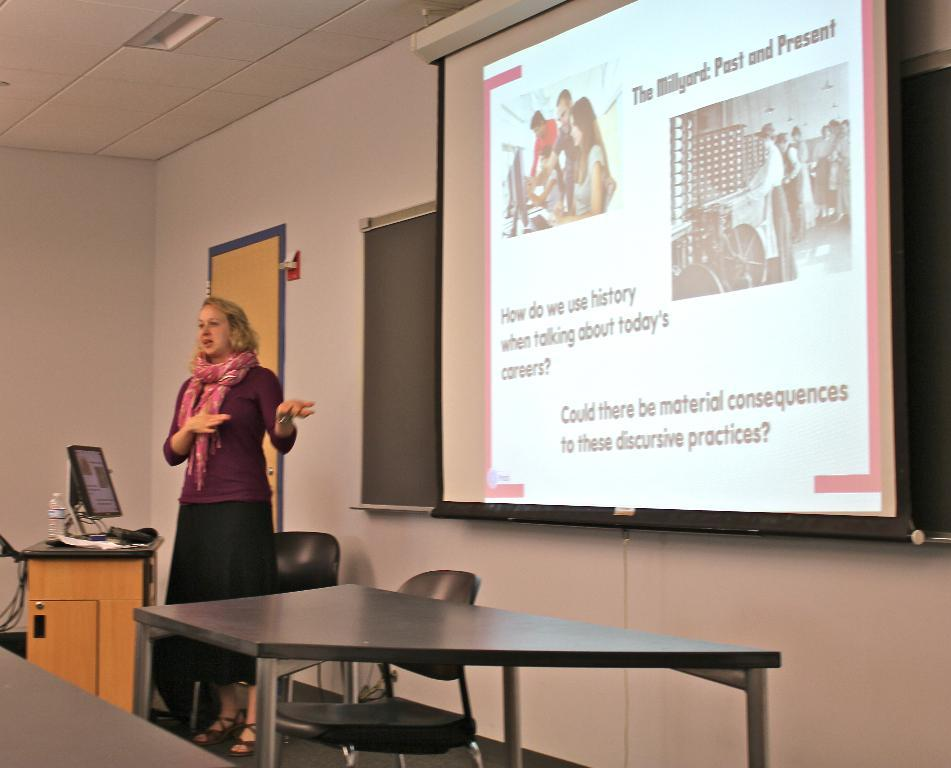Who is present in the image? There is a woman in the image. What is the woman doing in the image? The woman is standing in the image. What can be seen on the wall or screen in the image? There is a projected image in the image. What type of furniture is present in the image? There is a chair and a table in the image. What type of stitch is the woman using to sew the rule in the image? There is no stitch or rule present in the image; it only features a woman, a projected image, and some furniture. 